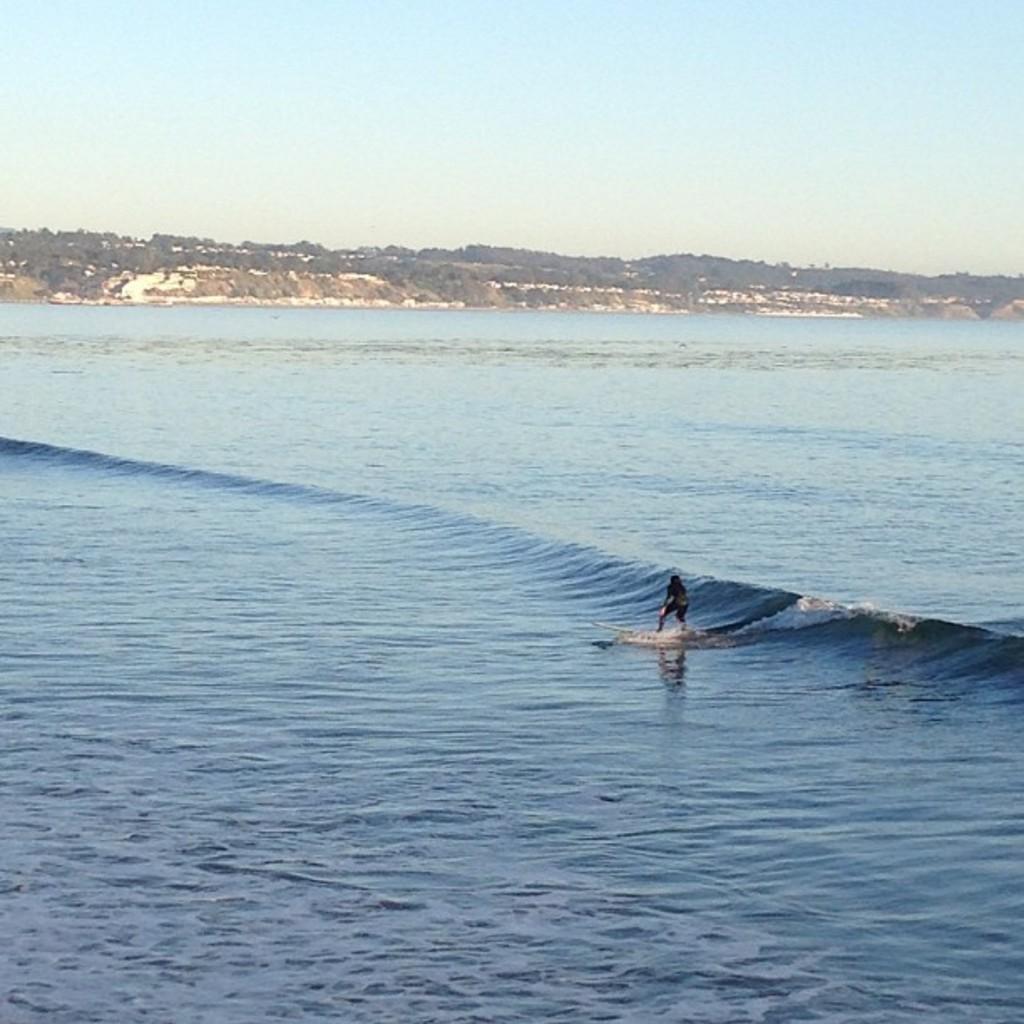Please provide a concise description of this image. In the foreground of this picture, there is a person surfing in the water. In the background, we can see trees and the sky. 